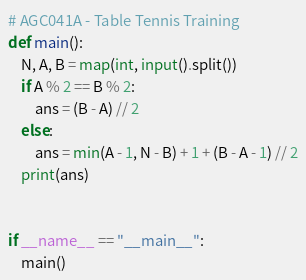Convert code to text. <code><loc_0><loc_0><loc_500><loc_500><_Python_># AGC041A - Table Tennis Training
def main():
    N, A, B = map(int, input().split())
    if A % 2 == B % 2:
        ans = (B - A) // 2
    else:
        ans = min(A - 1, N - B) + 1 + (B - A - 1) // 2
    print(ans)


if __name__ == "__main__":
    main()
</code> 